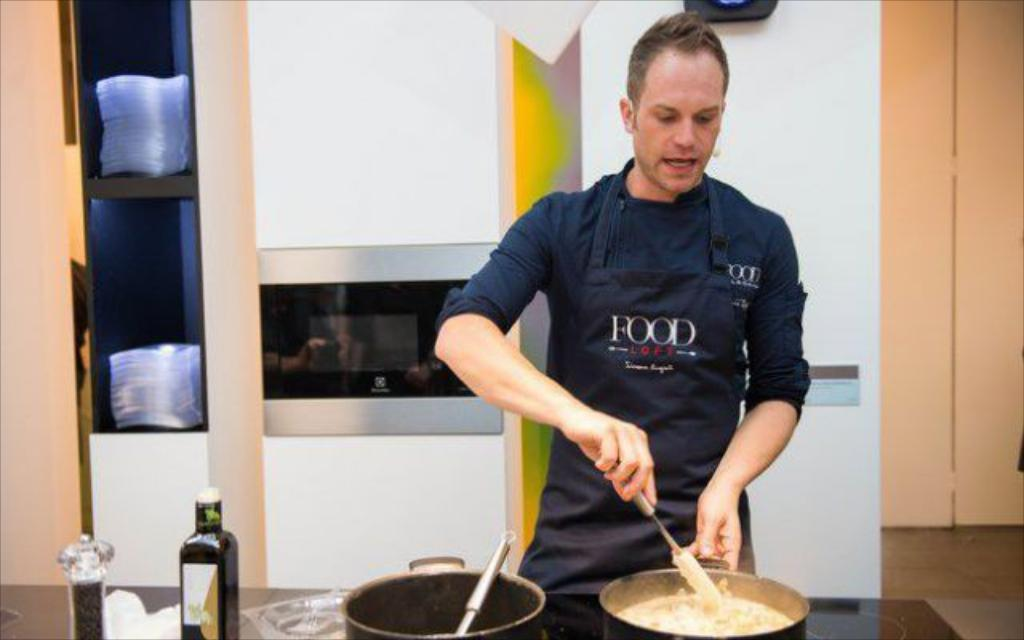What can be seen on the table in the image? There are objects on the table in the image. Can you describe the person in the image? There is a person standing in the image. What is located in the background of the image? There are objects in a shelf and a wall visible in the background of the image. What type of string is being used by the slave in the image? There is no slave or string present in the image. Is there a church visible in the image? There is no church visible in the image. 